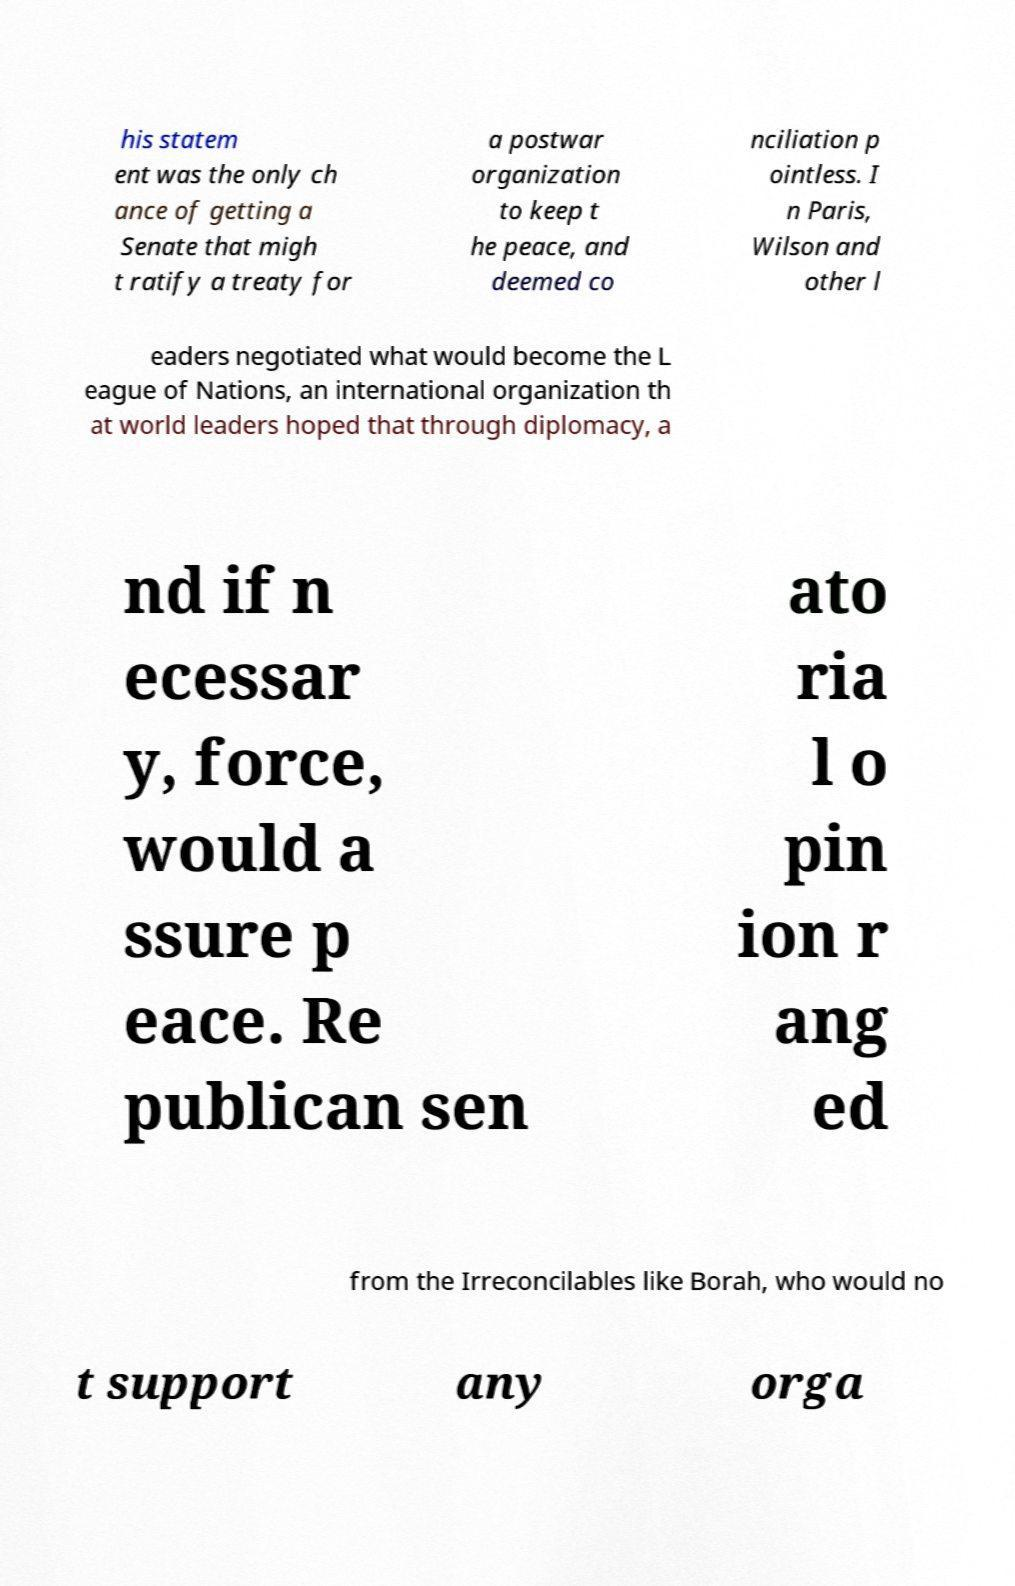I need the written content from this picture converted into text. Can you do that? his statem ent was the only ch ance of getting a Senate that migh t ratify a treaty for a postwar organization to keep t he peace, and deemed co nciliation p ointless. I n Paris, Wilson and other l eaders negotiated what would become the L eague of Nations, an international organization th at world leaders hoped that through diplomacy, a nd if n ecessar y, force, would a ssure p eace. Re publican sen ato ria l o pin ion r ang ed from the Irreconcilables like Borah, who would no t support any orga 